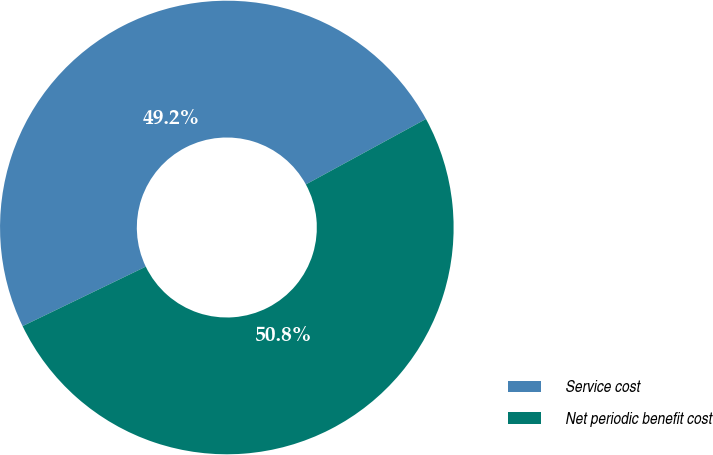<chart> <loc_0><loc_0><loc_500><loc_500><pie_chart><fcel>Service cost<fcel>Net periodic benefit cost<nl><fcel>49.22%<fcel>50.78%<nl></chart> 